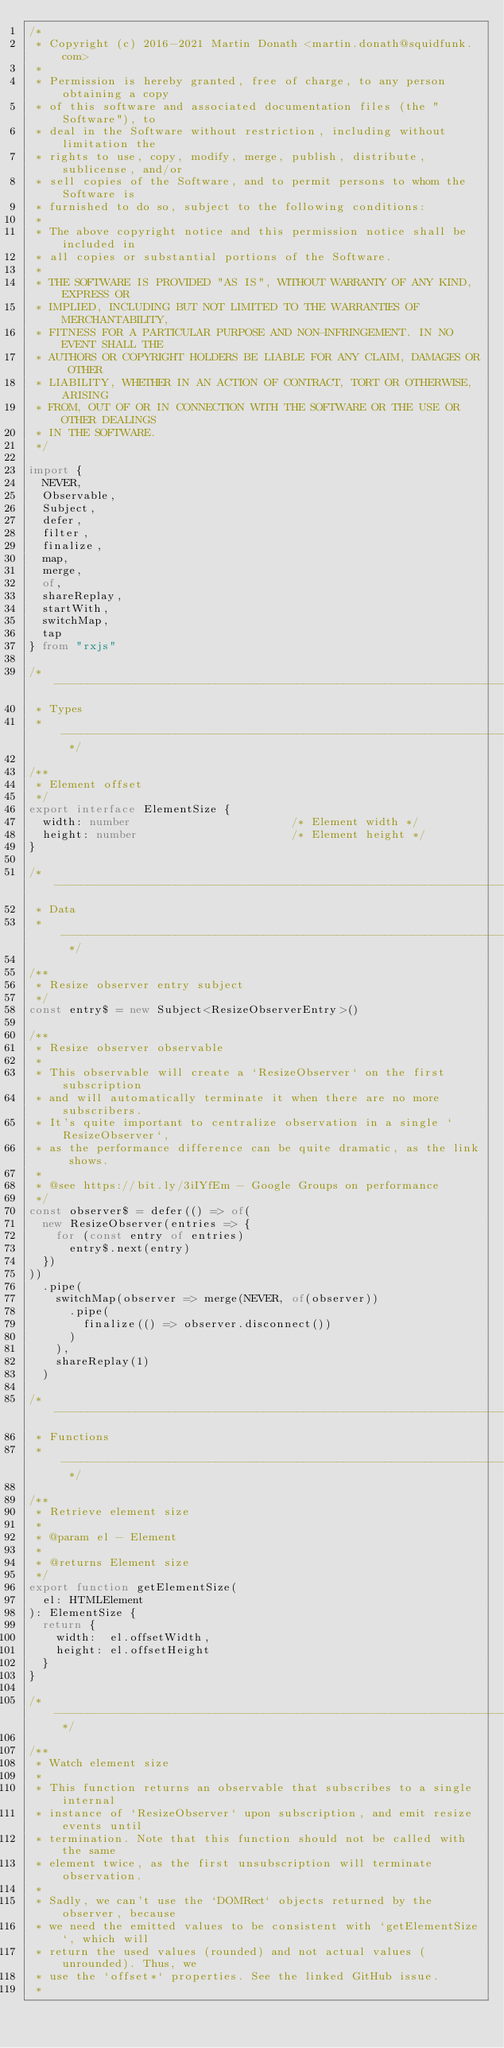Convert code to text. <code><loc_0><loc_0><loc_500><loc_500><_TypeScript_>/*
 * Copyright (c) 2016-2021 Martin Donath <martin.donath@squidfunk.com>
 *
 * Permission is hereby granted, free of charge, to any person obtaining a copy
 * of this software and associated documentation files (the "Software"), to
 * deal in the Software without restriction, including without limitation the
 * rights to use, copy, modify, merge, publish, distribute, sublicense, and/or
 * sell copies of the Software, and to permit persons to whom the Software is
 * furnished to do so, subject to the following conditions:
 *
 * The above copyright notice and this permission notice shall be included in
 * all copies or substantial portions of the Software.
 *
 * THE SOFTWARE IS PROVIDED "AS IS", WITHOUT WARRANTY OF ANY KIND, EXPRESS OR
 * IMPLIED, INCLUDING BUT NOT LIMITED TO THE WARRANTIES OF MERCHANTABILITY,
 * FITNESS FOR A PARTICULAR PURPOSE AND NON-INFRINGEMENT. IN NO EVENT SHALL THE
 * AUTHORS OR COPYRIGHT HOLDERS BE LIABLE FOR ANY CLAIM, DAMAGES OR OTHER
 * LIABILITY, WHETHER IN AN ACTION OF CONTRACT, TORT OR OTHERWISE, ARISING
 * FROM, OUT OF OR IN CONNECTION WITH THE SOFTWARE OR THE USE OR OTHER DEALINGS
 * IN THE SOFTWARE.
 */

import {
  NEVER,
  Observable,
  Subject,
  defer,
  filter,
  finalize,
  map,
  merge,
  of,
  shareReplay,
  startWith,
  switchMap,
  tap
} from "rxjs"

/* ----------------------------------------------------------------------------
 * Types
 * ------------------------------------------------------------------------- */

/**
 * Element offset
 */
export interface ElementSize {
  width: number                        /* Element width */
  height: number                       /* Element height */
}

/* ----------------------------------------------------------------------------
 * Data
 * ------------------------------------------------------------------------- */

/**
 * Resize observer entry subject
 */
const entry$ = new Subject<ResizeObserverEntry>()

/**
 * Resize observer observable
 *
 * This observable will create a `ResizeObserver` on the first subscription
 * and will automatically terminate it when there are no more subscribers.
 * It's quite important to centralize observation in a single `ResizeObserver`,
 * as the performance difference can be quite dramatic, as the link shows.
 *
 * @see https://bit.ly/3iIYfEm - Google Groups on performance
 */
const observer$ = defer(() => of(
  new ResizeObserver(entries => {
    for (const entry of entries)
      entry$.next(entry)
  })
))
  .pipe(
    switchMap(observer => merge(NEVER, of(observer))
      .pipe(
        finalize(() => observer.disconnect())
      )
    ),
    shareReplay(1)
  )

/* ----------------------------------------------------------------------------
 * Functions
 * ------------------------------------------------------------------------- */

/**
 * Retrieve element size
 *
 * @param el - Element
 *
 * @returns Element size
 */
export function getElementSize(
  el: HTMLElement
): ElementSize {
  return {
    width:  el.offsetWidth,
    height: el.offsetHeight
  }
}

/* ------------------------------------------------------------------------- */

/**
 * Watch element size
 *
 * This function returns an observable that subscribes to a single internal
 * instance of `ResizeObserver` upon subscription, and emit resize events until
 * termination. Note that this function should not be called with the same
 * element twice, as the first unsubscription will terminate observation.
 *
 * Sadly, we can't use the `DOMRect` objects returned by the observer, because
 * we need the emitted values to be consistent with `getElementSize`, which will
 * return the used values (rounded) and not actual values (unrounded). Thus, we
 * use the `offset*` properties. See the linked GitHub issue.
 *</code> 